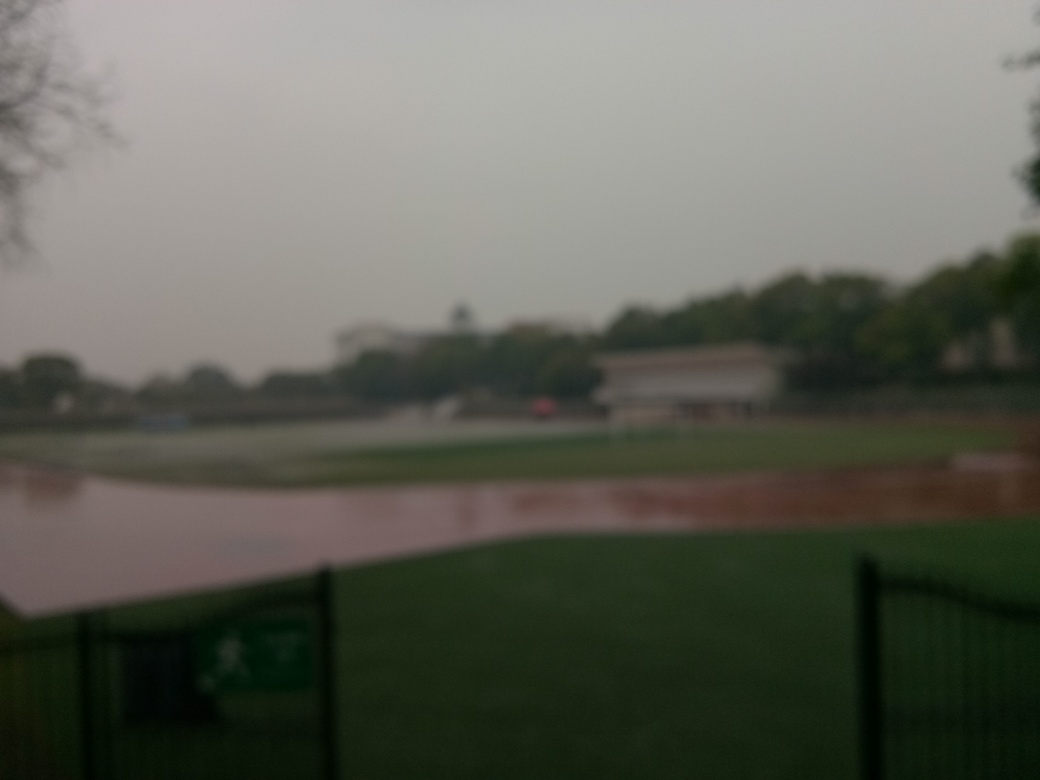Can you suggest what the weather might have been like when this photo was taken? Considering the overall haziness and muted colors in the image, it appears likely that the weather was overcast or foggy. Such conditions usually result in diffused lighting, which might contribute to the low contrast and lack of sharp contours seen in this photo. 